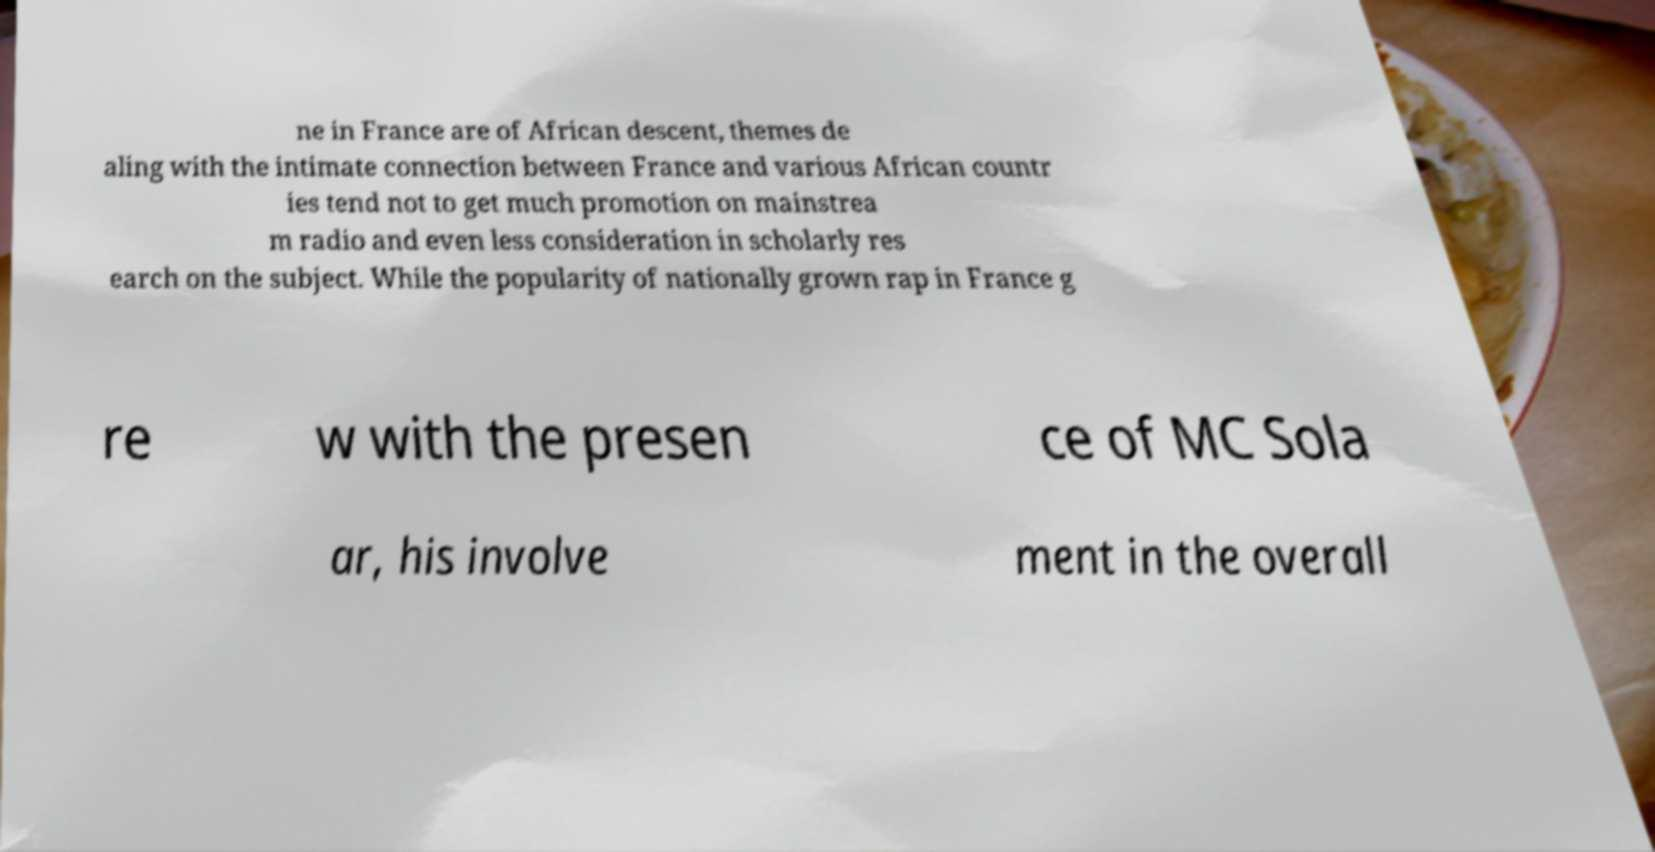Can you accurately transcribe the text from the provided image for me? ne in France are of African descent, themes de aling with the intimate connection between France and various African countr ies tend not to get much promotion on mainstrea m radio and even less consideration in scholarly res earch on the subject. While the popularity of nationally grown rap in France g re w with the presen ce of MC Sola ar, his involve ment in the overall 